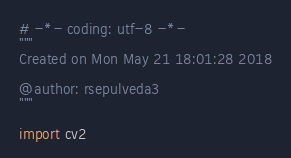Convert code to text. <code><loc_0><loc_0><loc_500><loc_500><_Python_># -*- coding: utf-8 -*-
"""
Created on Mon May 21 18:01:28 2018

@author: rsepulveda3
"""

import cv2</code> 